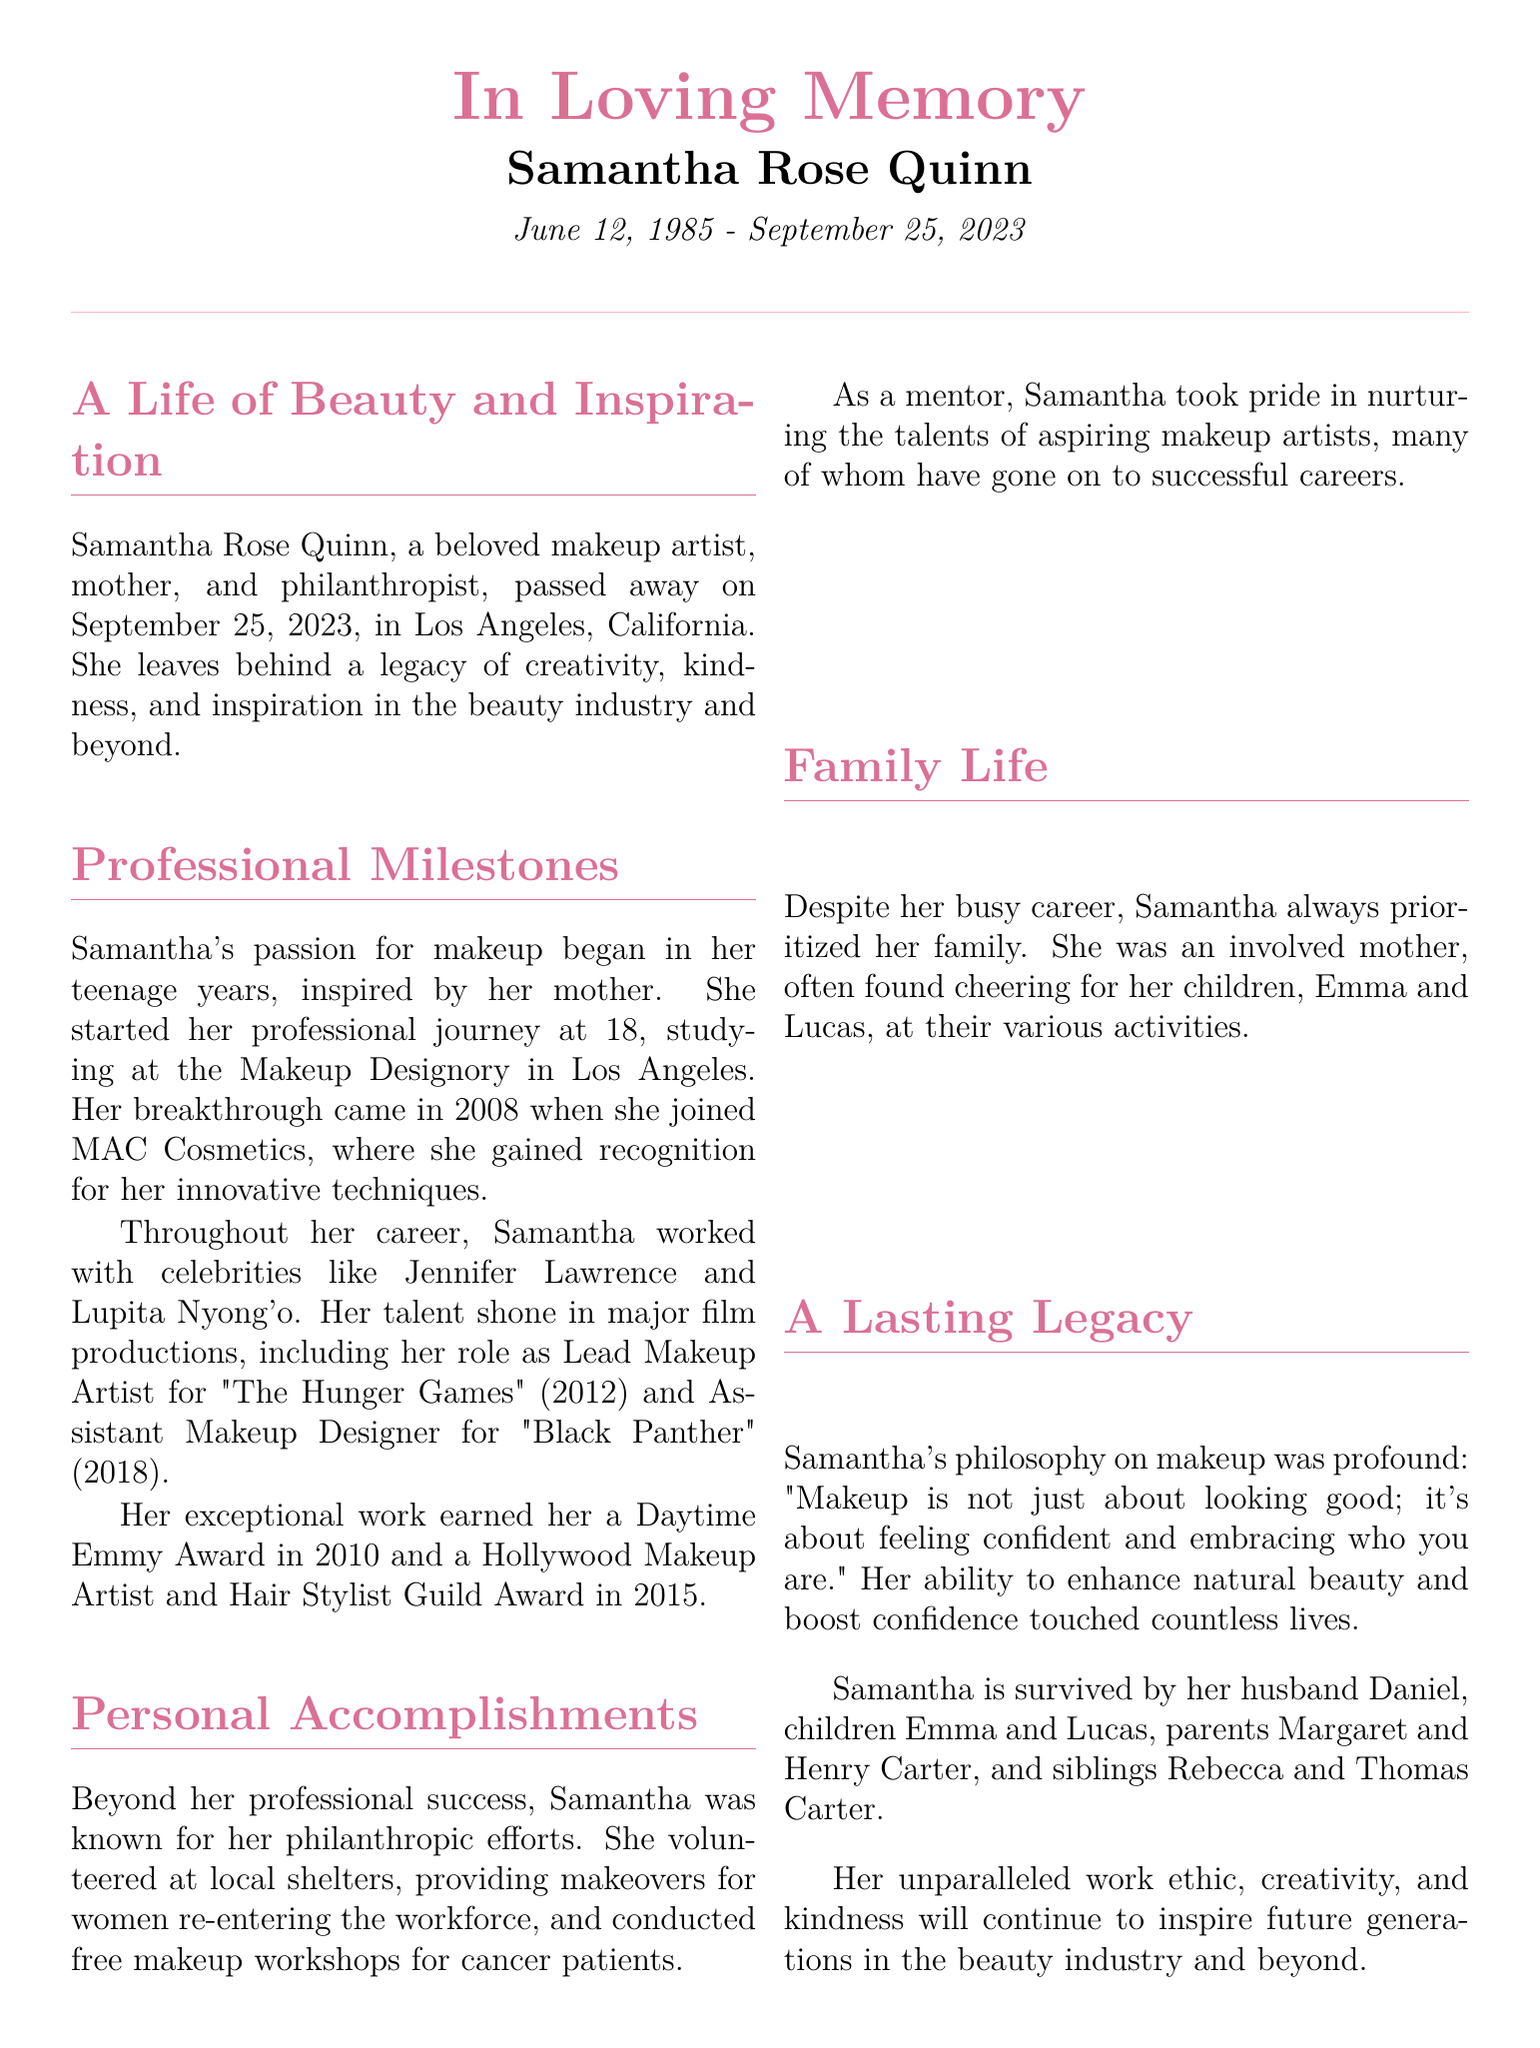What is the full name of the makeup artist? The full name of the makeup artist mentioned in the document is Samantha Rose Quinn.
Answer: Samantha Rose Quinn When was Samantha Rose Quinn born? The document states that Samantha was born on June 12, 1985.
Answer: June 12, 1985 What year did Samantha join MAC Cosmetics? The document specifies that Samantha joined MAC Cosmetics in 2008.
Answer: 2008 Which film did Samantha work on as the Lead Makeup Artist? The document mentions that she was the Lead Makeup Artist for "The Hunger Games" in 2012.
Answer: The Hunger Games What award did Samantha win in 2010? According to the document, Samantha won a Daytime Emmy Award in 2010.
Answer: Daytime Emmy Award How many children did Samantha have? The document indicates that Samantha had two children, Emma and Lucas.
Answer: Two What was Samantha’s philosophy on makeup? The document outlines her philosophy as: "Makeup is not just about looking good; it's about feeling confident and embracing who you are."
Answer: "Makeup is not just about looking good; it's about feeling confident and embracing who you are." What was one of Samantha's philanthropic efforts mentioned? The document states that she volunteered at local shelters providing makeovers for women re-entering the workforce.
Answer: Providing makeovers for women re-entering the workforce Who survives Samantha? The document lists her husband, children, parents, and siblings as survivors.
Answer: Husband Daniel, children Emma and Lucas, parents Margaret and Henry Carter, siblings Rebecca and Thomas Carter 